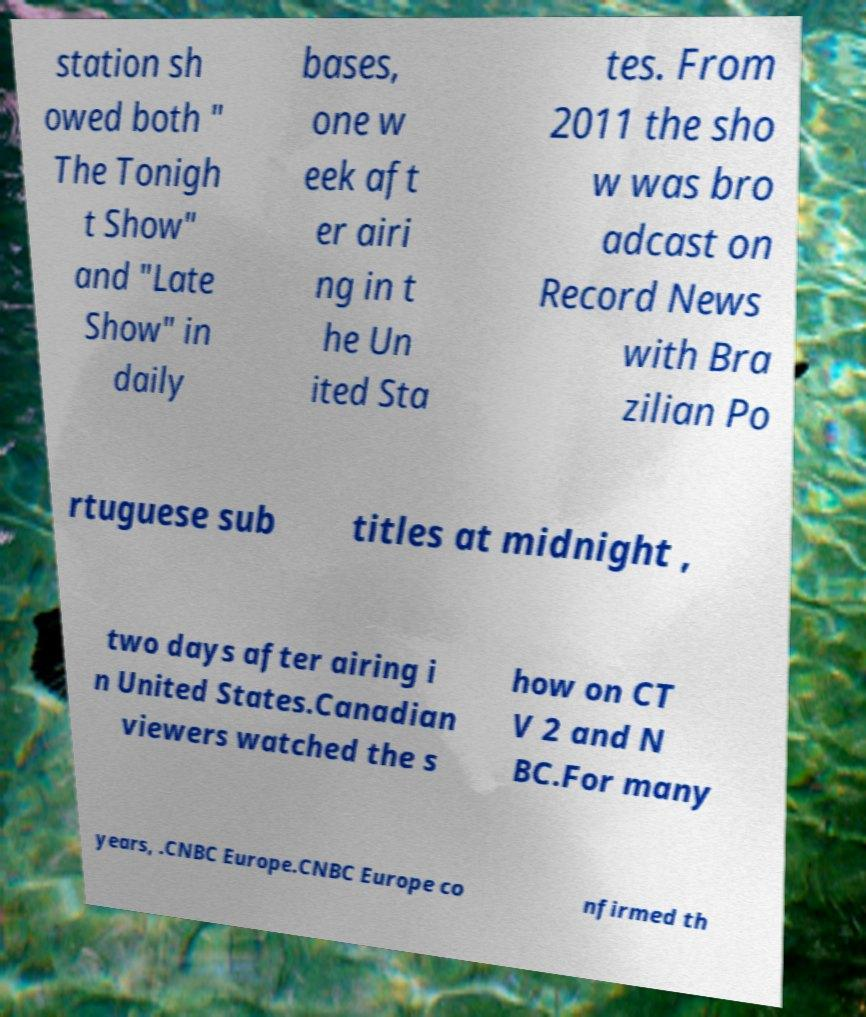There's text embedded in this image that I need extracted. Can you transcribe it verbatim? station sh owed both " The Tonigh t Show" and "Late Show" in daily bases, one w eek aft er airi ng in t he Un ited Sta tes. From 2011 the sho w was bro adcast on Record News with Bra zilian Po rtuguese sub titles at midnight , two days after airing i n United States.Canadian viewers watched the s how on CT V 2 and N BC.For many years, .CNBC Europe.CNBC Europe co nfirmed th 